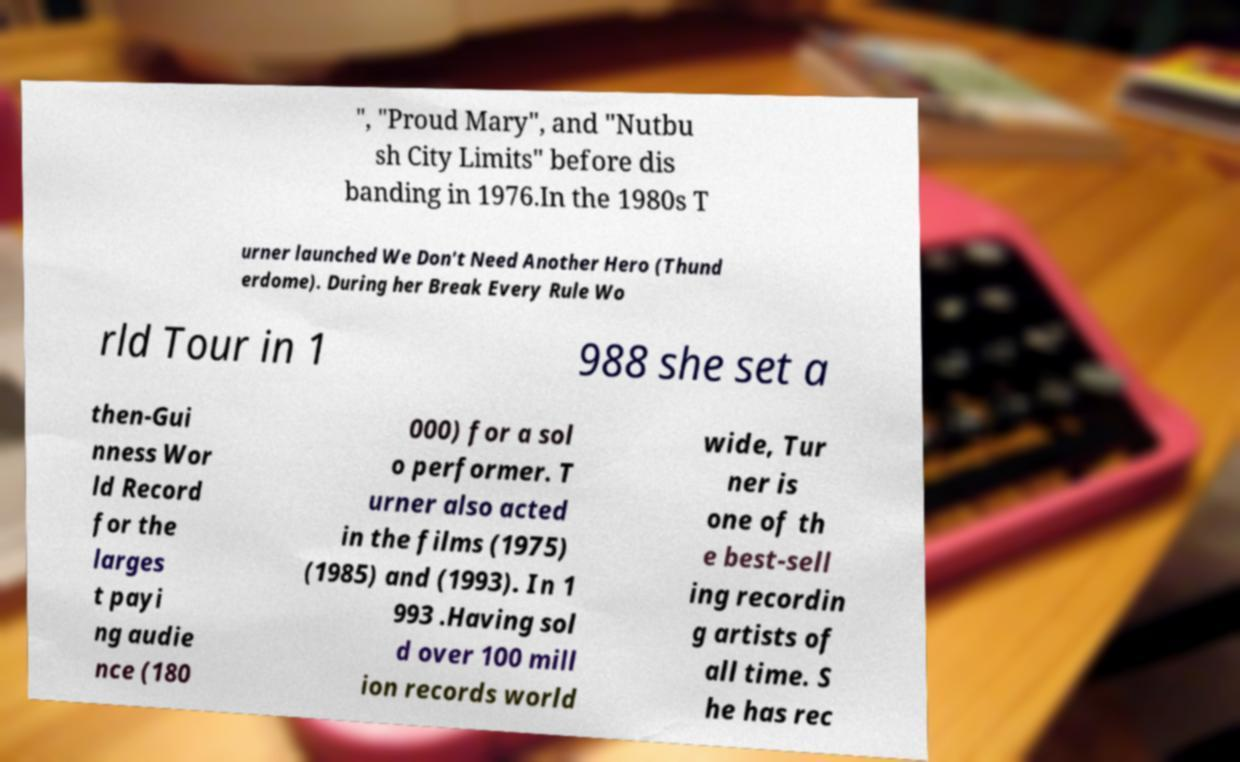Please read and relay the text visible in this image. What does it say? ", "Proud Mary", and "Nutbu sh City Limits" before dis banding in 1976.In the 1980s T urner launched We Don't Need Another Hero (Thund erdome). During her Break Every Rule Wo rld Tour in 1 988 she set a then-Gui nness Wor ld Record for the larges t payi ng audie nce (180 000) for a sol o performer. T urner also acted in the films (1975) (1985) and (1993). In 1 993 .Having sol d over 100 mill ion records world wide, Tur ner is one of th e best-sell ing recordin g artists of all time. S he has rec 